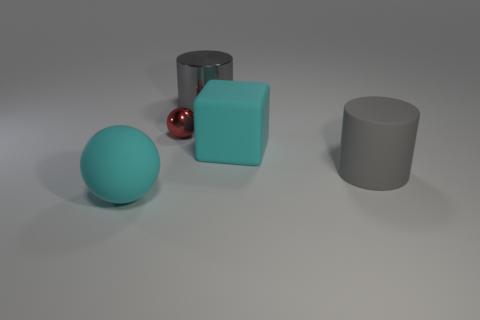Subtract all cyan balls. How many balls are left? 1 Subtract all balls. How many objects are left? 3 Add 3 small metallic cylinders. How many objects exist? 8 Add 1 gray metal things. How many gray metal things exist? 2 Subtract 1 red balls. How many objects are left? 4 Subtract all blue spheres. Subtract all blue blocks. How many spheres are left? 2 Subtract all blue shiny cylinders. Subtract all spheres. How many objects are left? 3 Add 3 gray metallic things. How many gray metallic things are left? 4 